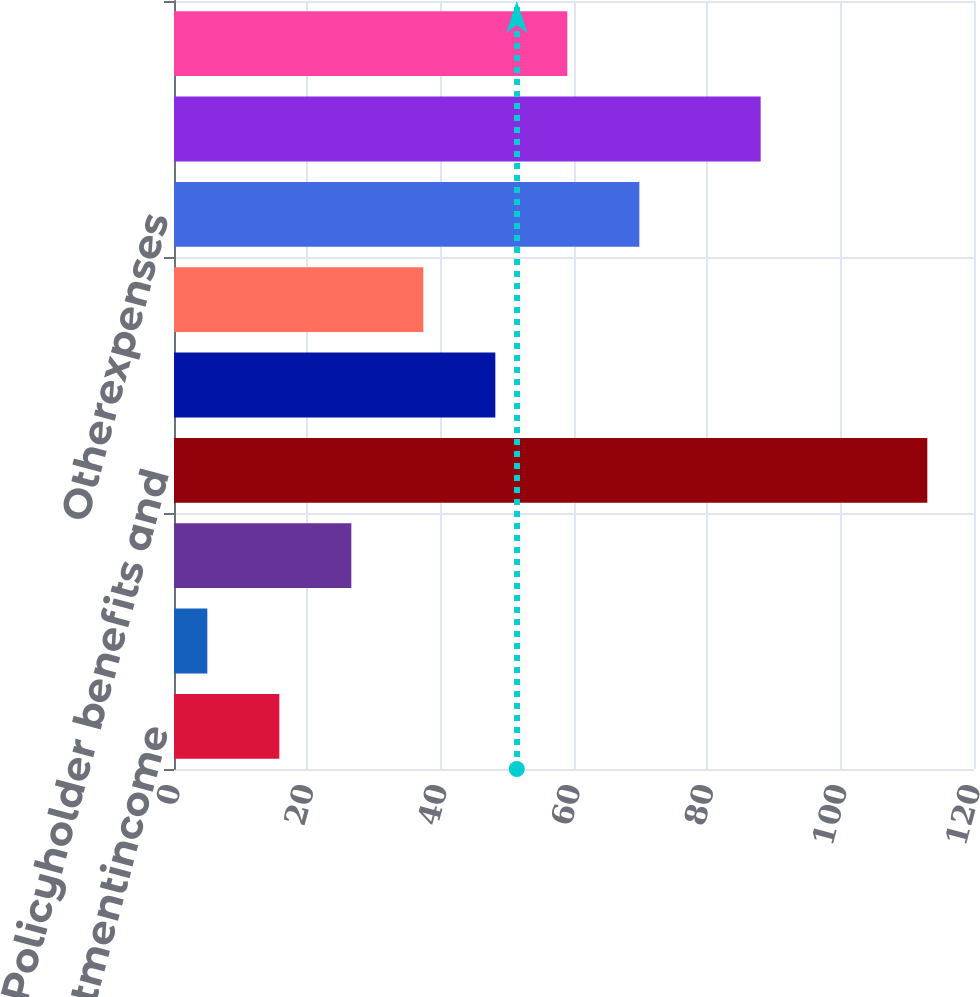<chart> <loc_0><loc_0><loc_500><loc_500><bar_chart><fcel>Netinvestmentincome<fcel>Otherrevenues<fcel>Totaloperatingrevenues<fcel>Policyholder benefits and<fcel>CapitalizationofDAC<fcel>AmortizationofDACandVOBA<fcel>Otherexpenses<fcel>Totaloperatingexpenses<fcel>Unnamed: 8<nl><fcel>15.8<fcel>5<fcel>26.6<fcel>113<fcel>48.2<fcel>37.4<fcel>69.8<fcel>88<fcel>59<nl></chart> 